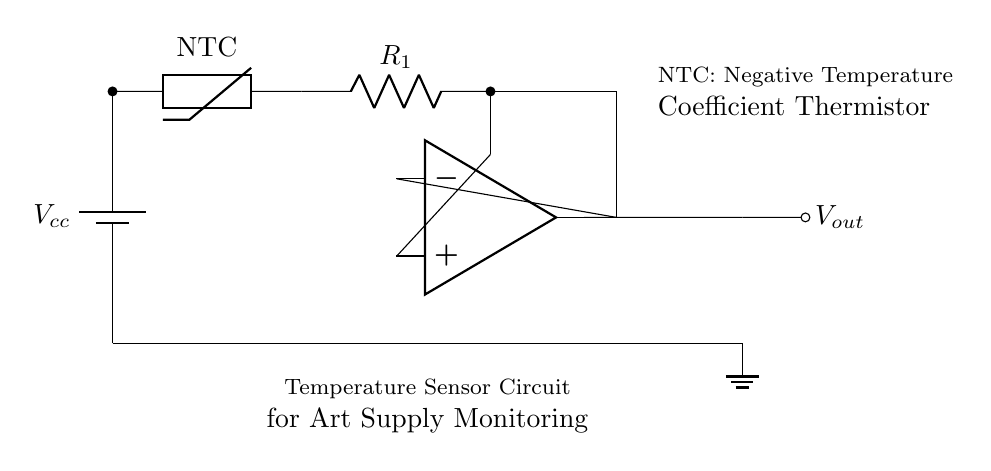What type of thermistor is used in this circuit? The circuit diagram specifies that it uses an NTC (Negative Temperature Coefficient) thermistor, which means it decreases its resistance as the temperature increases.
Answer: NTC What is the output voltage variable labeled? The output voltage in the circuit is labeled as Vout, indicating this is where the signal output can be taken for monitoring purposes.
Answer: Vout How many resistors are present in the circuit? The diagram clearly shows one resistor labeled R1 connected in series with the thermistor, so there is one resistor in the circuit.
Answer: One What is the purpose of the op-amp in this circuit? The operational amplifier (op-amp) is used to amplify the voltage change caused by changes in temperature as detected by the thermistor, which is essential for accurate readings.
Answer: Amplification What is the voltage source in this circuit? The circuit uses a battery labeled Vcc as its power supply source, which provides the necessary voltage for the operation of the components in the circuit.
Answer: Vcc Which component connects the thermistor and the op-amp? The resistor R1 connects the thermistor to the op-amp, establishing a relationship between their readings and allowing for temperature detection via voltage changes.
Answer: Resistor R1 Why is this circuit suitable for monitoring heat-sensitive art supplies? This circuit is designed specifically as a temperature sensor, allowing users to monitor heat-sensitive materials effectively by detecting changes in temperature through the thermistor and providing feedback via the output voltage.
Answer: Temperature sensing 